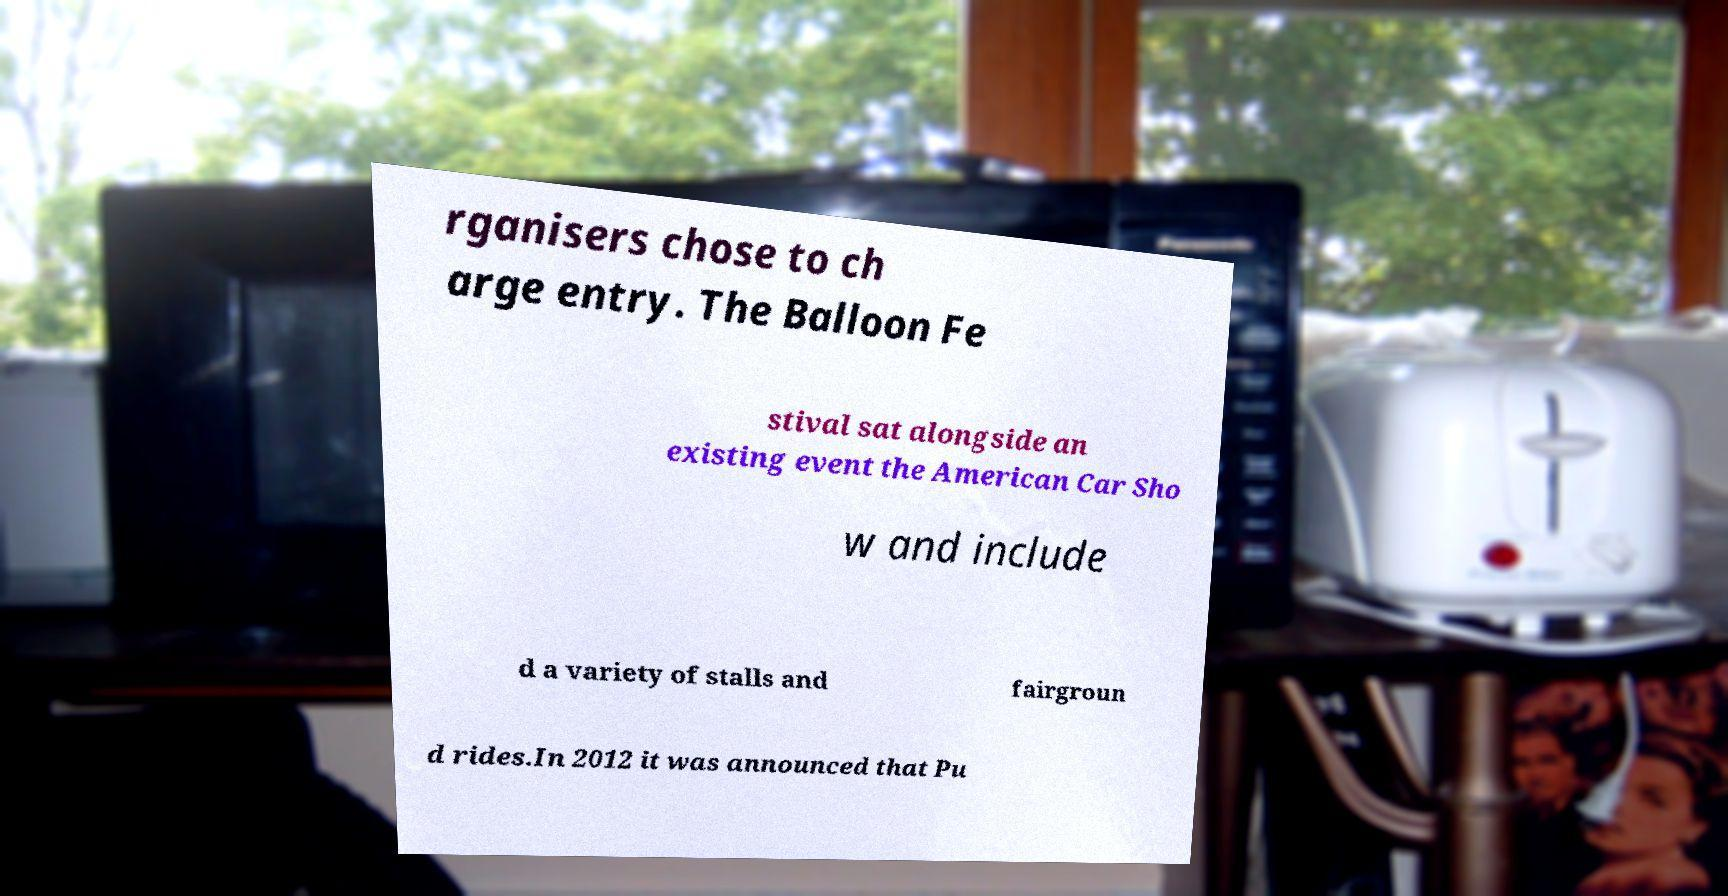Please identify and transcribe the text found in this image. rganisers chose to ch arge entry. The Balloon Fe stival sat alongside an existing event the American Car Sho w and include d a variety of stalls and fairgroun d rides.In 2012 it was announced that Pu 